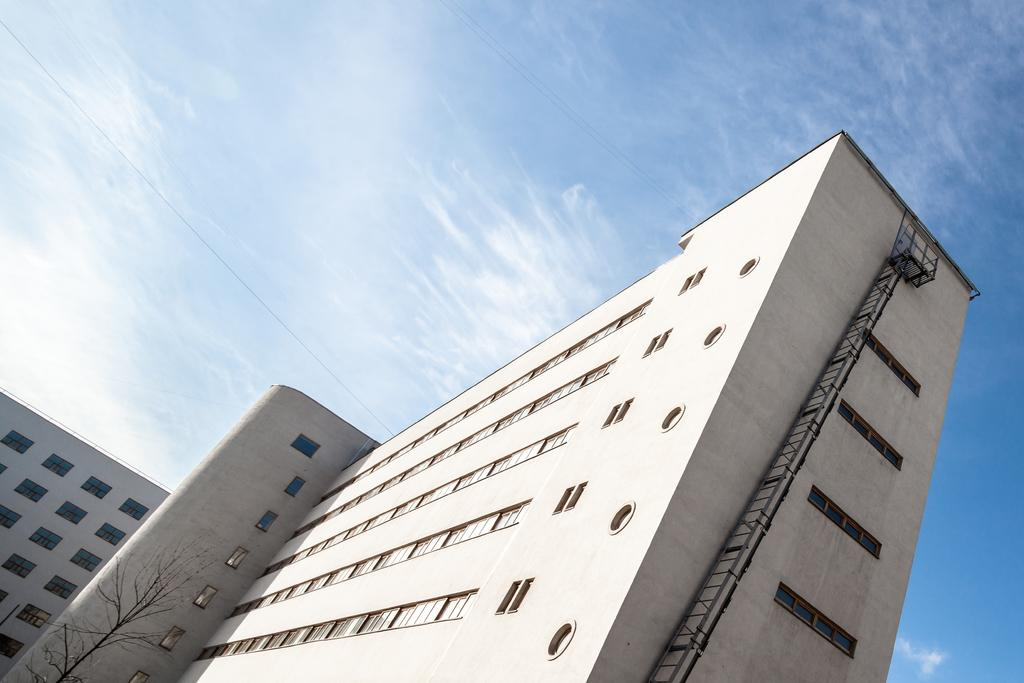What type of structures can be seen in the image? There are buildings in the image. Can you describe any specific features of the buildings? A ladder is attached to a building in the image. What other objects or elements can be seen near the buildings? There is a tree near a building in the image. What is visible in the background of the image? The sky is visible in the background of the image. What can be observed in the sky? Clouds are present in the sky. What type of bells can be heard ringing in the image? There are no bells present in the image, and therefore no sound can be heard. Can you tell me where the father is located in the image? There is no father present in the image. 